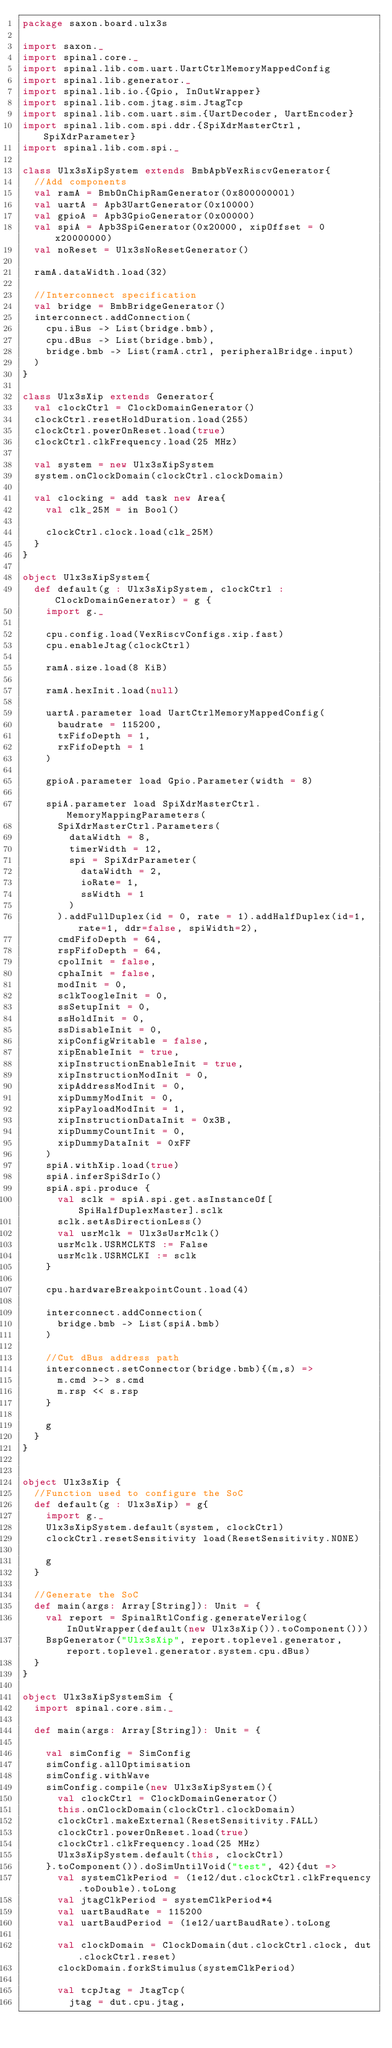Convert code to text. <code><loc_0><loc_0><loc_500><loc_500><_Scala_>package saxon.board.ulx3s

import saxon._
import spinal.core._
import spinal.lib.com.uart.UartCtrlMemoryMappedConfig
import spinal.lib.generator._
import spinal.lib.io.{Gpio, InOutWrapper}
import spinal.lib.com.jtag.sim.JtagTcp
import spinal.lib.com.uart.sim.{UartDecoder, UartEncoder}
import spinal.lib.com.spi.ddr.{SpiXdrMasterCtrl, SpiXdrParameter}
import spinal.lib.com.spi._

class Ulx3sXipSystem extends BmbApbVexRiscvGenerator{
  //Add components
  val ramA = BmbOnChipRamGenerator(0x80000000l)
  val uartA = Apb3UartGenerator(0x10000)
  val gpioA = Apb3GpioGenerator(0x00000)
  val spiA = Apb3SpiGenerator(0x20000, xipOffset = 0x20000000)
  val noReset = Ulx3sNoResetGenerator()

  ramA.dataWidth.load(32)

  //Interconnect specification
  val bridge = BmbBridgeGenerator()
  interconnect.addConnection(
    cpu.iBus -> List(bridge.bmb),
    cpu.dBus -> List(bridge.bmb),
    bridge.bmb -> List(ramA.ctrl, peripheralBridge.input)
  )
}

class Ulx3sXip extends Generator{
  val clockCtrl = ClockDomainGenerator()
  clockCtrl.resetHoldDuration.load(255)
  clockCtrl.powerOnReset.load(true)
  clockCtrl.clkFrequency.load(25 MHz)

  val system = new Ulx3sXipSystem
  system.onClockDomain(clockCtrl.clockDomain)

  val clocking = add task new Area{
    val clk_25M = in Bool()

    clockCtrl.clock.load(clk_25M)
  }
}

object Ulx3sXipSystem{
  def default(g : Ulx3sXipSystem, clockCtrl : ClockDomainGenerator) = g {
    import g._

    cpu.config.load(VexRiscvConfigs.xip.fast)
    cpu.enableJtag(clockCtrl)

    ramA.size.load(8 KiB)

    ramA.hexInit.load(null)

    uartA.parameter load UartCtrlMemoryMappedConfig(
      baudrate = 115200,
      txFifoDepth = 1,
      rxFifoDepth = 1
    )

    gpioA.parameter load Gpio.Parameter(width = 8)

    spiA.parameter load SpiXdrMasterCtrl.MemoryMappingParameters(
      SpiXdrMasterCtrl.Parameters(
        dataWidth = 8,
        timerWidth = 12,
        spi = SpiXdrParameter(
          dataWidth = 2,
          ioRate= 1,
          ssWidth = 1
        )
      ).addFullDuplex(id = 0, rate = 1).addHalfDuplex(id=1, rate=1, ddr=false, spiWidth=2),
      cmdFifoDepth = 64,
      rspFifoDepth = 64,
      cpolInit = false,
      cphaInit = false,
      modInit = 0,
      sclkToogleInit = 0,
      ssSetupInit = 0,
      ssHoldInit = 0,
      ssDisableInit = 0,
      xipConfigWritable = false,
      xipEnableInit = true,
      xipInstructionEnableInit = true,
      xipInstructionModInit = 0,
      xipAddressModInit = 0,
      xipDummyModInit = 0,
      xipPayloadModInit = 1,
      xipInstructionDataInit = 0x3B,
      xipDummyCountInit = 0,
      xipDummyDataInit = 0xFF
    )
    spiA.withXip.load(true)
    spiA.inferSpiSdrIo()
    spiA.spi.produce {
      val sclk = spiA.spi.get.asInstanceOf[SpiHalfDuplexMaster].sclk
      sclk.setAsDirectionLess()
      val usrMclk = Ulx3sUsrMclk()
      usrMclk.USRMCLKTS := False
      usrMclk.USRMCLKI := sclk
    }
    
    cpu.hardwareBreakpointCount.load(4)

    interconnect.addConnection(
      bridge.bmb -> List(spiA.bmb)
    )

    //Cut dBus address path
    interconnect.setConnector(bridge.bmb){(m,s) =>
      m.cmd >-> s.cmd
      m.rsp << s.rsp
    }

    g
  }
}


object Ulx3sXip {
  //Function used to configure the SoC
  def default(g : Ulx3sXip) = g{
    import g._
    Ulx3sXipSystem.default(system, clockCtrl)
    clockCtrl.resetSensitivity load(ResetSensitivity.NONE)
    
    g
  }

  //Generate the SoC
  def main(args: Array[String]): Unit = {
    val report = SpinalRtlConfig.generateVerilog(InOutWrapper(default(new Ulx3sXip()).toComponent()))
    BspGenerator("Ulx3sXip", report.toplevel.generator, report.toplevel.generator.system.cpu.dBus)
  }
}

object Ulx3sXipSystemSim {
  import spinal.core.sim._

  def main(args: Array[String]): Unit = {

    val simConfig = SimConfig
    simConfig.allOptimisation
    simConfig.withWave
    simConfig.compile(new Ulx3sXipSystem(){
      val clockCtrl = ClockDomainGenerator()
      this.onClockDomain(clockCtrl.clockDomain)
      clockCtrl.makeExternal(ResetSensitivity.FALL)
      clockCtrl.powerOnReset.load(true)
      clockCtrl.clkFrequency.load(25 MHz)
      Ulx3sXipSystem.default(this, clockCtrl)
    }.toComponent()).doSimUntilVoid("test", 42){dut =>
      val systemClkPeriod = (1e12/dut.clockCtrl.clkFrequency.toDouble).toLong
      val jtagClkPeriod = systemClkPeriod*4
      val uartBaudRate = 115200
      val uartBaudPeriod = (1e12/uartBaudRate).toLong

      val clockDomain = ClockDomain(dut.clockCtrl.clock, dut.clockCtrl.reset)
      clockDomain.forkStimulus(systemClkPeriod)

      val tcpJtag = JtagTcp(
        jtag = dut.cpu.jtag,</code> 